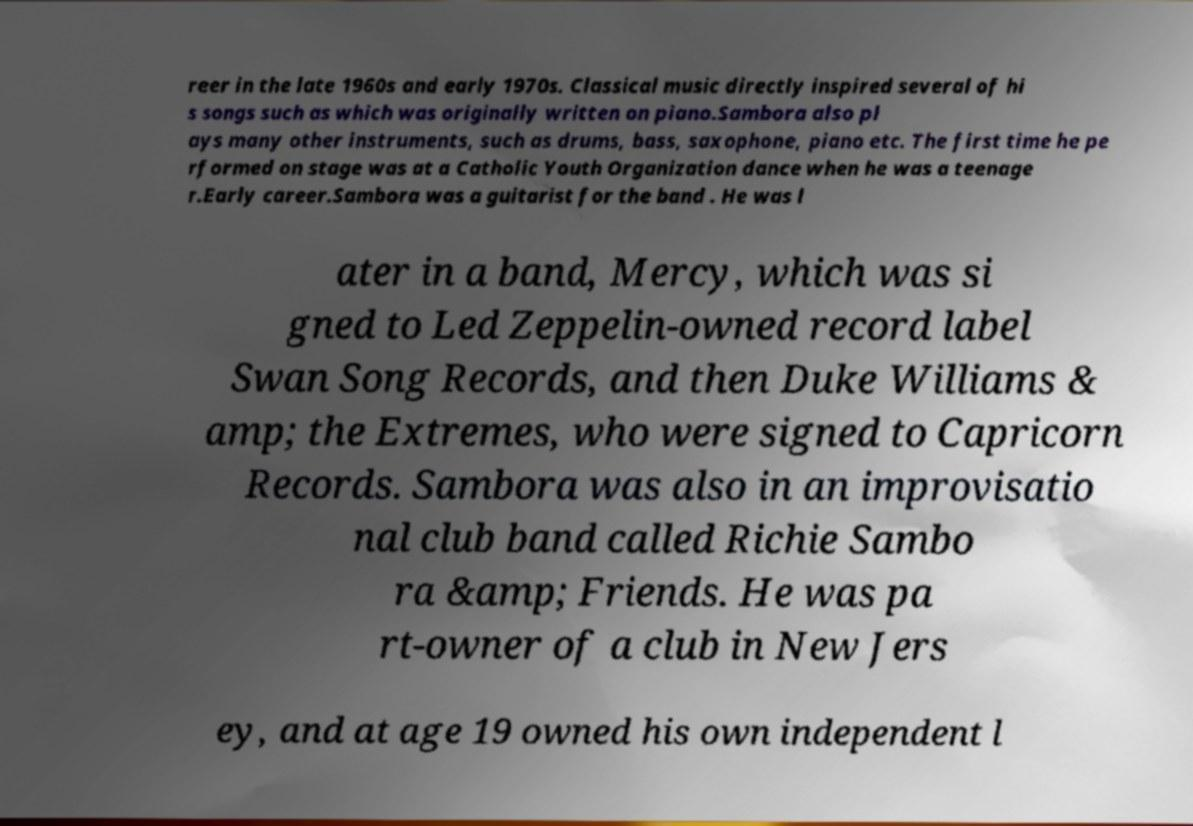I need the written content from this picture converted into text. Can you do that? reer in the late 1960s and early 1970s. Classical music directly inspired several of hi s songs such as which was originally written on piano.Sambora also pl ays many other instruments, such as drums, bass, saxophone, piano etc. The first time he pe rformed on stage was at a Catholic Youth Organization dance when he was a teenage r.Early career.Sambora was a guitarist for the band . He was l ater in a band, Mercy, which was si gned to Led Zeppelin-owned record label Swan Song Records, and then Duke Williams & amp; the Extremes, who were signed to Capricorn Records. Sambora was also in an improvisatio nal club band called Richie Sambo ra &amp; Friends. He was pa rt-owner of a club in New Jers ey, and at age 19 owned his own independent l 